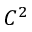<formula> <loc_0><loc_0><loc_500><loc_500>C ^ { 2 }</formula> 